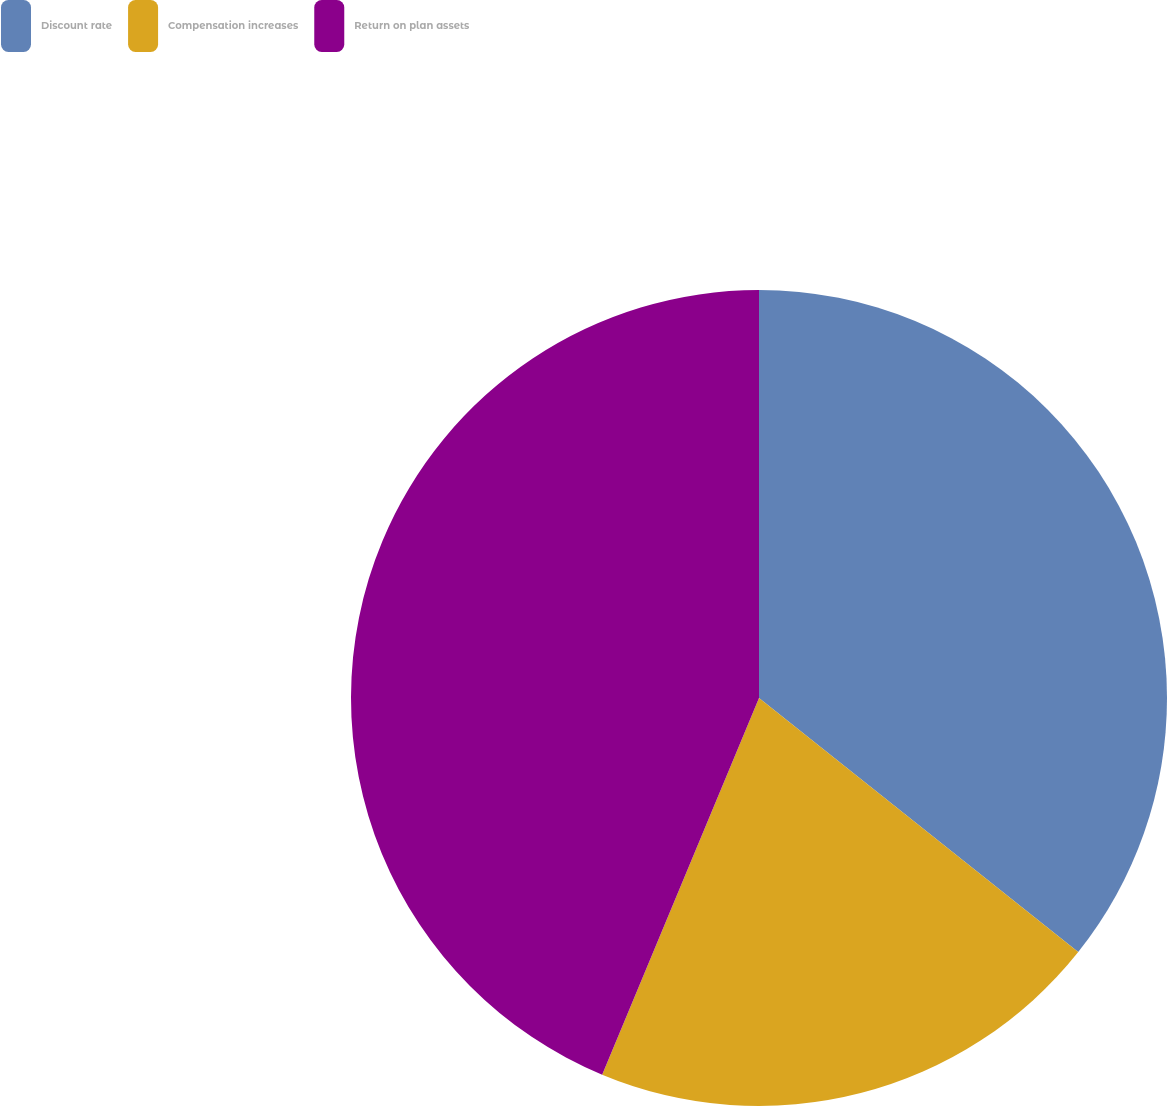<chart> <loc_0><loc_0><loc_500><loc_500><pie_chart><fcel>Discount rate<fcel>Compensation increases<fcel>Return on plan assets<nl><fcel>35.7%<fcel>20.58%<fcel>43.72%<nl></chart> 